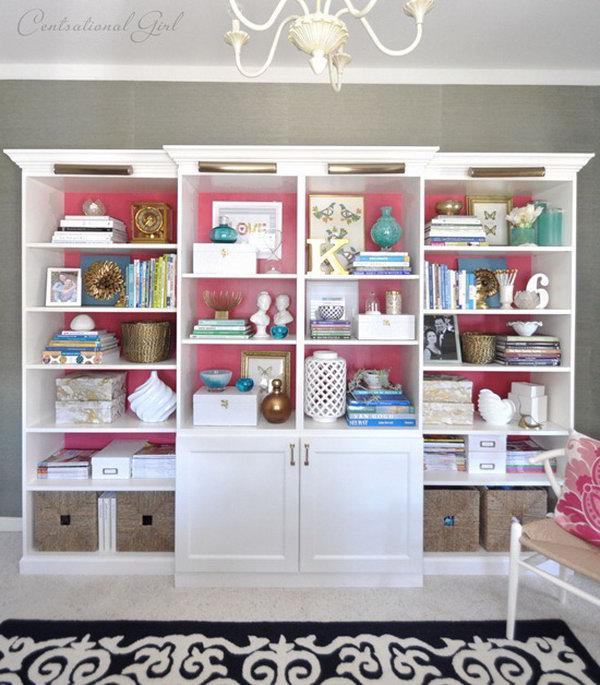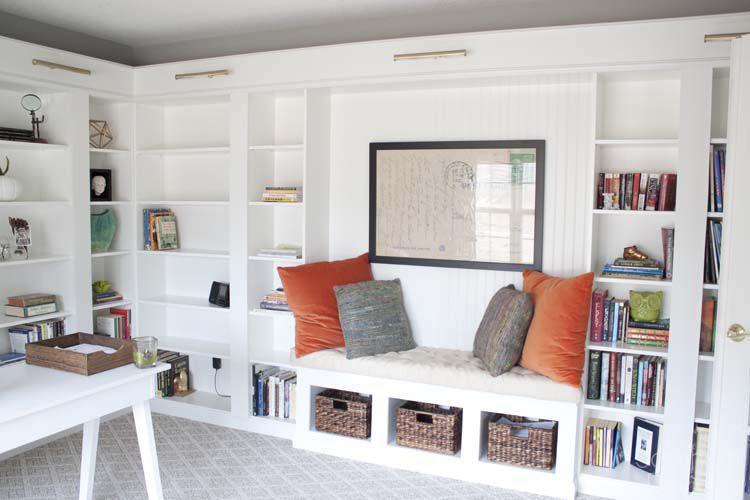The first image is the image on the left, the second image is the image on the right. Examine the images to the left and right. Is the description "Each image includes an empty white storage unit that reaches toward the ceiling, and at least one image shows a storage unit on a light wood floor." accurate? Answer yes or no. No. The first image is the image on the left, the second image is the image on the right. For the images shown, is this caption "The shelving unit in the image on the right is empty." true? Answer yes or no. No. 